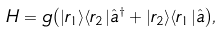Convert formula to latex. <formula><loc_0><loc_0><loc_500><loc_500>H = g { \left ( | r _ { 1 } \rangle \langle r _ { 2 } | \hat { a } ^ { \dagger } + | r _ { 2 } \rangle \langle r _ { 1 } | \hat { a } \right ) } ,</formula> 